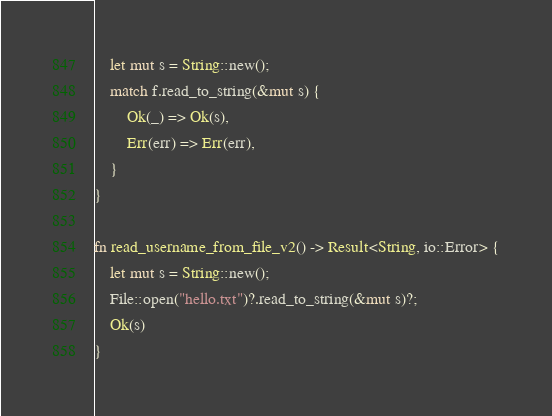<code> <loc_0><loc_0><loc_500><loc_500><_Rust_>    let mut s = String::new();
    match f.read_to_string(&mut s) {
        Ok(_) => Ok(s),
        Err(err) => Err(err),
    }
}

fn read_username_from_file_v2() -> Result<String, io::Error> {
    let mut s = String::new();
    File::open("hello.txt")?.read_to_string(&mut s)?;
    Ok(s)
}
</code> 